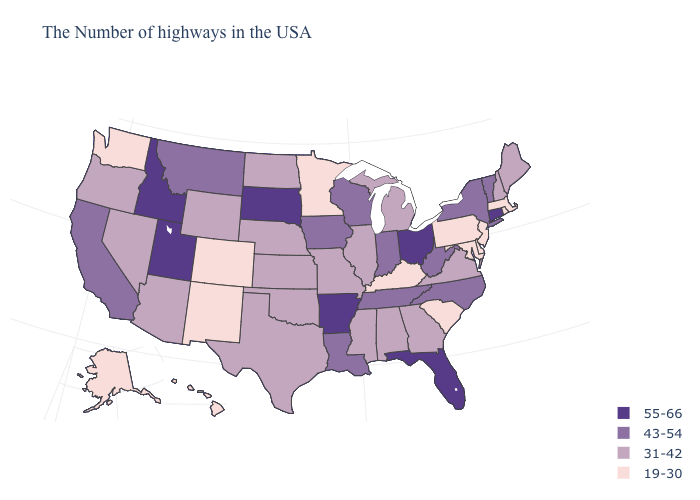What is the lowest value in states that border New Jersey?
Concise answer only. 19-30. Name the states that have a value in the range 31-42?
Answer briefly. Maine, New Hampshire, Virginia, Georgia, Michigan, Alabama, Illinois, Mississippi, Missouri, Kansas, Nebraska, Oklahoma, Texas, North Dakota, Wyoming, Arizona, Nevada, Oregon. Does New Jersey have the highest value in the Northeast?
Keep it brief. No. How many symbols are there in the legend?
Keep it brief. 4. How many symbols are there in the legend?
Short answer required. 4. What is the highest value in the USA?
Be succinct. 55-66. Does Washington have the highest value in the USA?
Answer briefly. No. Name the states that have a value in the range 19-30?
Quick response, please. Massachusetts, Rhode Island, New Jersey, Delaware, Maryland, Pennsylvania, South Carolina, Kentucky, Minnesota, Colorado, New Mexico, Washington, Alaska, Hawaii. What is the value of Arizona?
Write a very short answer. 31-42. Does the first symbol in the legend represent the smallest category?
Quick response, please. No. Name the states that have a value in the range 55-66?
Quick response, please. Connecticut, Ohio, Florida, Arkansas, South Dakota, Utah, Idaho. Which states have the highest value in the USA?
Concise answer only. Connecticut, Ohio, Florida, Arkansas, South Dakota, Utah, Idaho. What is the value of Washington?
Short answer required. 19-30. Name the states that have a value in the range 43-54?
Answer briefly. Vermont, New York, North Carolina, West Virginia, Indiana, Tennessee, Wisconsin, Louisiana, Iowa, Montana, California. What is the value of Vermont?
Give a very brief answer. 43-54. 